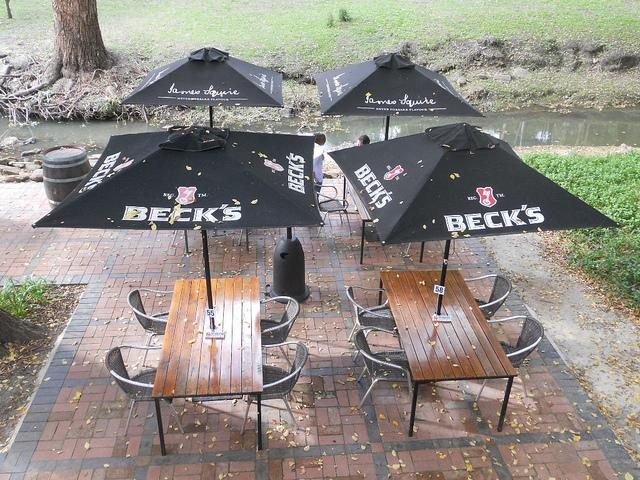What do the umbrellas offer those who sit here? shade 